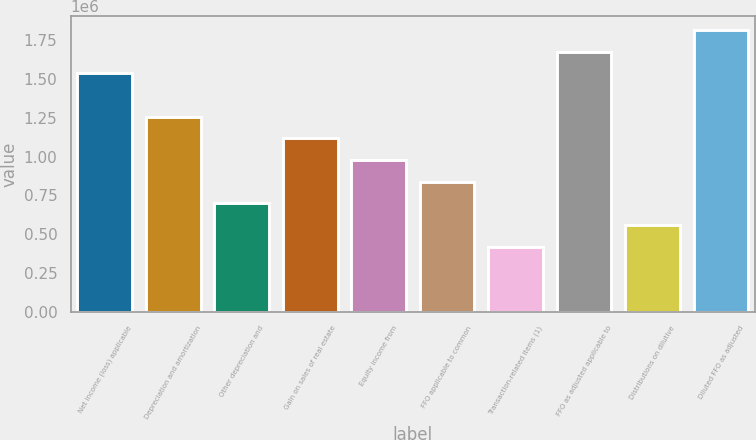Convert chart. <chart><loc_0><loc_0><loc_500><loc_500><bar_chart><fcel>Net income (loss) applicable<fcel>Depreciation and amortization<fcel>Other depreciation and<fcel>Gain on sales of real estate<fcel>Equity income from<fcel>FFO applicable to common<fcel>Transaction-related items (1)<fcel>FFO as adjusted applicable to<fcel>Distributions on dilutive<fcel>Diluted FFO as adjusted<nl><fcel>1.53551e+06<fcel>1.25633e+06<fcel>697960<fcel>1.11674e+06<fcel>977143<fcel>837551<fcel>418776<fcel>1.6751e+06<fcel>558368<fcel>1.81469e+06<nl></chart> 